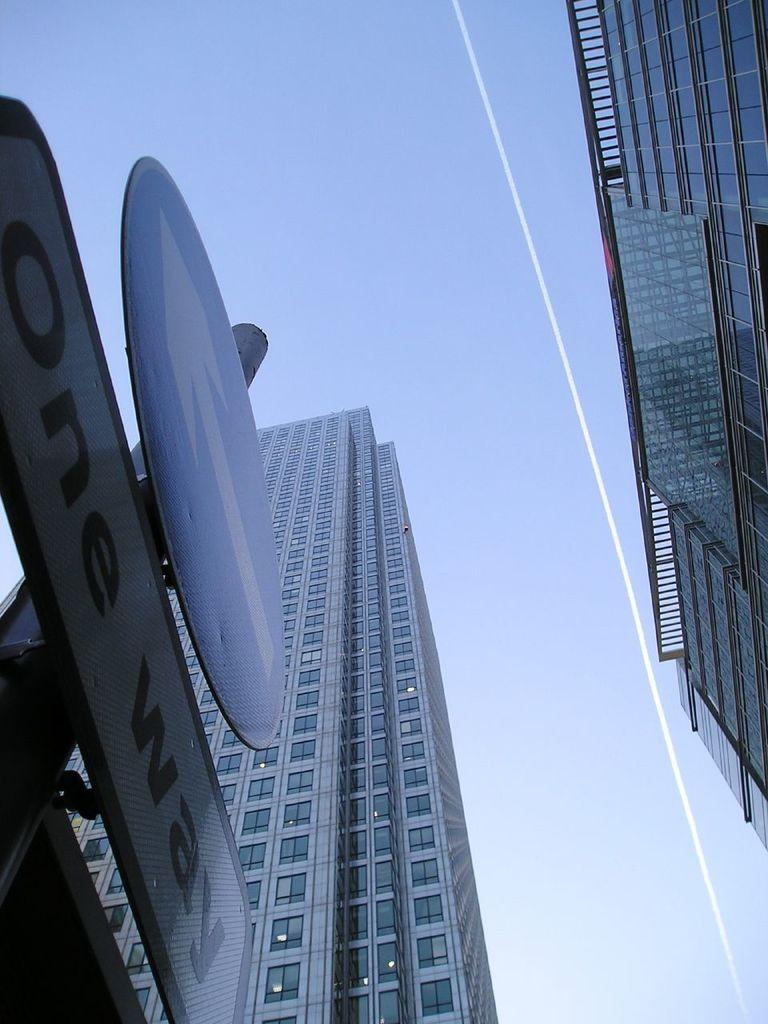What color is the sky in the image? The sky is blue in the image. What type of structures can be seen in the image? There are buildings in the image. What feature is present on some of the buildings? There are glass windows in the image. What type of information might be displayed on the buildings? There are signboards in the image, which might display information or advertisements. What type of kitty is sitting on the table during the feast in the image? There is no kitty or feast present in the image; it features buildings with glass windows and signboards. 